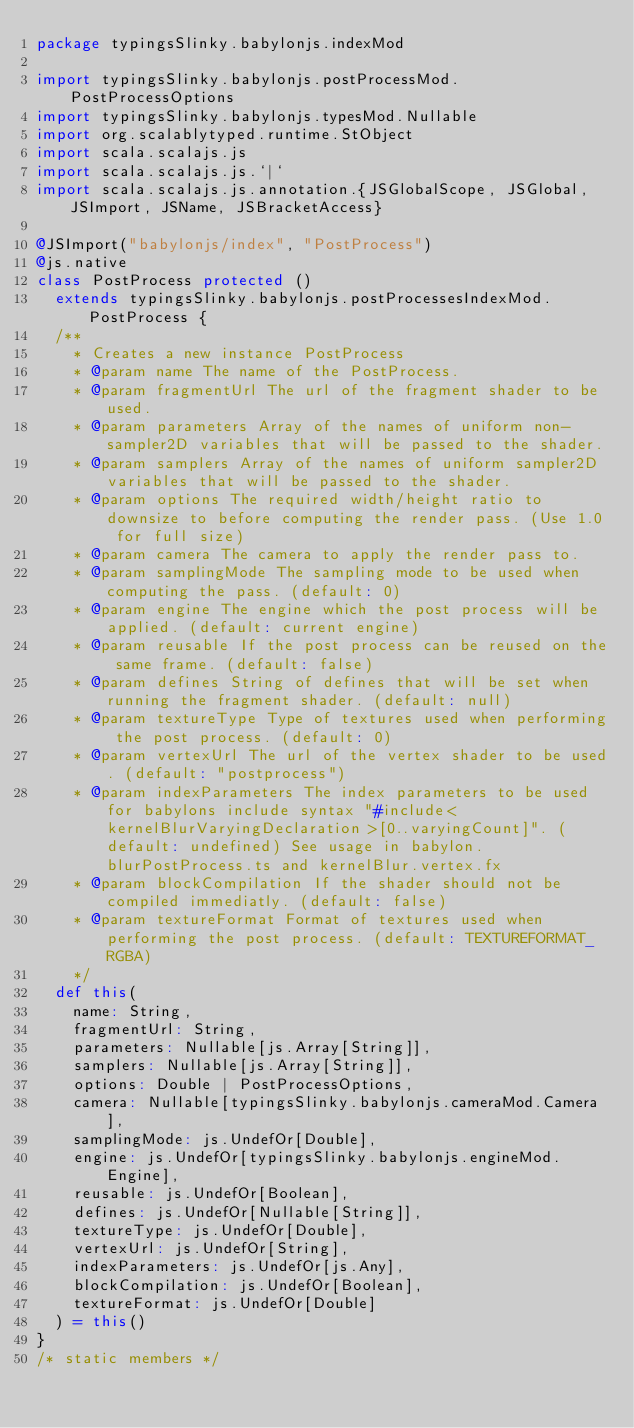<code> <loc_0><loc_0><loc_500><loc_500><_Scala_>package typingsSlinky.babylonjs.indexMod

import typingsSlinky.babylonjs.postProcessMod.PostProcessOptions
import typingsSlinky.babylonjs.typesMod.Nullable
import org.scalablytyped.runtime.StObject
import scala.scalajs.js
import scala.scalajs.js.`|`
import scala.scalajs.js.annotation.{JSGlobalScope, JSGlobal, JSImport, JSName, JSBracketAccess}

@JSImport("babylonjs/index", "PostProcess")
@js.native
class PostProcess protected ()
  extends typingsSlinky.babylonjs.postProcessesIndexMod.PostProcess {
  /**
    * Creates a new instance PostProcess
    * @param name The name of the PostProcess.
    * @param fragmentUrl The url of the fragment shader to be used.
    * @param parameters Array of the names of uniform non-sampler2D variables that will be passed to the shader.
    * @param samplers Array of the names of uniform sampler2D variables that will be passed to the shader.
    * @param options The required width/height ratio to downsize to before computing the render pass. (Use 1.0 for full size)
    * @param camera The camera to apply the render pass to.
    * @param samplingMode The sampling mode to be used when computing the pass. (default: 0)
    * @param engine The engine which the post process will be applied. (default: current engine)
    * @param reusable If the post process can be reused on the same frame. (default: false)
    * @param defines String of defines that will be set when running the fragment shader. (default: null)
    * @param textureType Type of textures used when performing the post process. (default: 0)
    * @param vertexUrl The url of the vertex shader to be used. (default: "postprocess")
    * @param indexParameters The index parameters to be used for babylons include syntax "#include<kernelBlurVaryingDeclaration>[0..varyingCount]". (default: undefined) See usage in babylon.blurPostProcess.ts and kernelBlur.vertex.fx
    * @param blockCompilation If the shader should not be compiled immediatly. (default: false)
    * @param textureFormat Format of textures used when performing the post process. (default: TEXTUREFORMAT_RGBA)
    */
  def this(
    name: String,
    fragmentUrl: String,
    parameters: Nullable[js.Array[String]],
    samplers: Nullable[js.Array[String]],
    options: Double | PostProcessOptions,
    camera: Nullable[typingsSlinky.babylonjs.cameraMod.Camera],
    samplingMode: js.UndefOr[Double],
    engine: js.UndefOr[typingsSlinky.babylonjs.engineMod.Engine],
    reusable: js.UndefOr[Boolean],
    defines: js.UndefOr[Nullable[String]],
    textureType: js.UndefOr[Double],
    vertexUrl: js.UndefOr[String],
    indexParameters: js.UndefOr[js.Any],
    blockCompilation: js.UndefOr[Boolean],
    textureFormat: js.UndefOr[Double]
  ) = this()
}
/* static members */</code> 